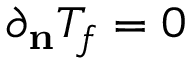<formula> <loc_0><loc_0><loc_500><loc_500>\partial _ { n } T _ { f } = 0</formula> 